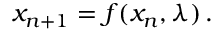Convert formula to latex. <formula><loc_0><loc_0><loc_500><loc_500>x _ { n + 1 } = f ( x _ { n } , \lambda ) \, .</formula> 